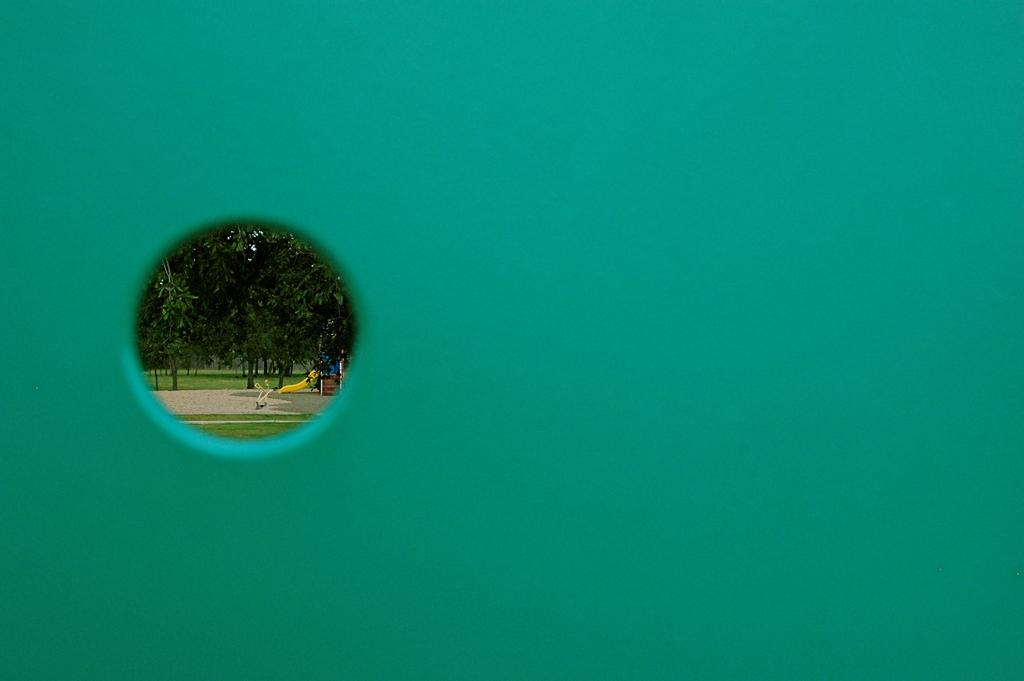What is present on the wall in the image? There is a hole in the wall in the image. What can be seen through the hole in the wall? Trees are visible through the hole in the wall. What type of path is in the image? There is a path in the image. What kind of playing item is present in the image? The playing item present in the image is not specified, but it is mentioned that there is one. What type of rice is being cooked in the tub in the image? There is no rice or tub present in the image. What kind of vase is placed on the path in the image? There is no vase present in the image. 